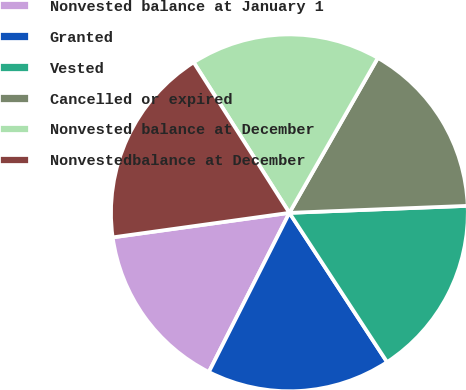<chart> <loc_0><loc_0><loc_500><loc_500><pie_chart><fcel>Nonvested balance at January 1<fcel>Granted<fcel>Vested<fcel>Cancelled or expired<fcel>Nonvested balance at December<fcel>Nonvestedbalance at December<nl><fcel>15.35%<fcel>16.68%<fcel>16.4%<fcel>16.12%<fcel>17.27%<fcel>18.18%<nl></chart> 